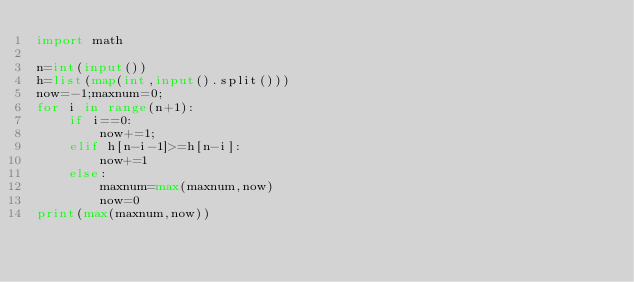<code> <loc_0><loc_0><loc_500><loc_500><_Python_>import math

n=int(input())
h=list(map(int,input().split()))
now=-1;maxnum=0;
for i in range(n+1):
    if i==0:
        now+=1;
    elif h[n-i-1]>=h[n-i]:
        now+=1
    else:
        maxnum=max(maxnum,now)
        now=0
print(max(maxnum,now))
</code> 